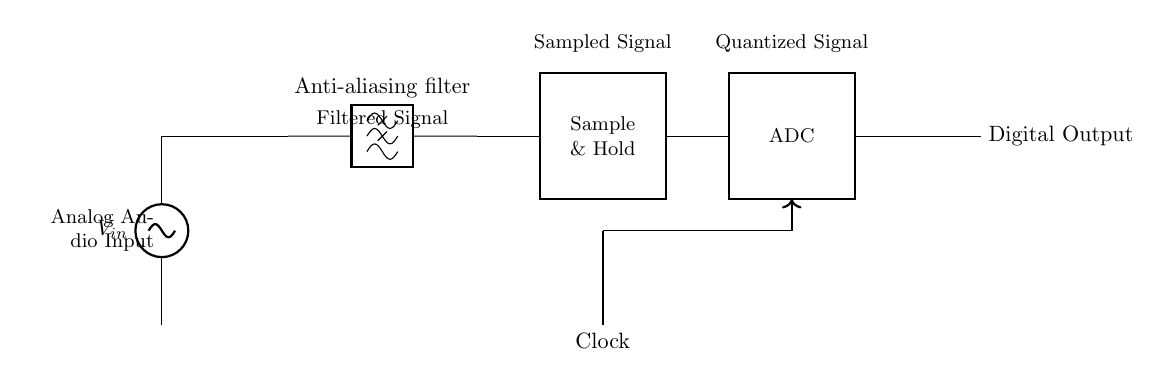What component filters the input audio signal? The anti-aliasing filter is the component responsible for filtering the input audio signal to prevent aliasing during the sampling process. It allows only frequencies below a certain threshold to pass, ensuring that high-frequency noise does not interfere with the audio signal quality.
Answer: Anti-aliasing filter What does the sample and hold circuit do? The sample and hold circuit captures and holds a sample of the analog signal for a specified period, which allows the Analog-to-Digital Converter (ADC) to process a stable signal instead of a continuously varying input. This step is crucial for accurate digital representation of the audio signal.
Answer: Holds the sample Which component converts the analog signal into a digital signal? The ADC (Analog-to-Digital Converter) is the component responsible for converting the sampled analog audio signal into a digital format, which can be processed by digital systems. This conversion process quantizes the amplitude of the analog signal into discrete values.
Answer: ADC How is the clock signal represented in the circuit? The clock signal is shown as an upward vertical line leading to a horizontal line connecting to the ADC, indicating that it synchronizes the sampling process and the operation of the ADC in converting the signal. The arrow suggests a direction of signal flow which is crucial for timing the sampling phases.
Answer: Upward line What is the purpose of anti-aliasing in this circuit? The purpose of anti-aliasing in this circuit is to eliminate high-frequency components from the audio signal prior to sampling, thereby preventing distortion that can occur when higher frequencies are misrepresented as lower frequencies in the digital signal. This filtering helps maintain the integrity of the audio during conversion.
Answer: To prevent aliasing What is the output of the ADC? The output of the ADC is the digital representation of the sampled analog audio signal, which can be processed and stored in a digital format. This output consists of discrete values corresponding to the quantized amplitudes of the input signal, allowing digital manipulation of the audio.
Answer: Digital Output What is the signal flow direction in the circuit? The signal flow direction starts from the analog audio input at the left side, moves through the anti-aliasing filter, passes through the sample and hold and then to the ADC, and finally exits as a digital output on the right side of the diagram. This flow illustrates the sequence of processing stages for the audio signal.
Answer: Left to right 